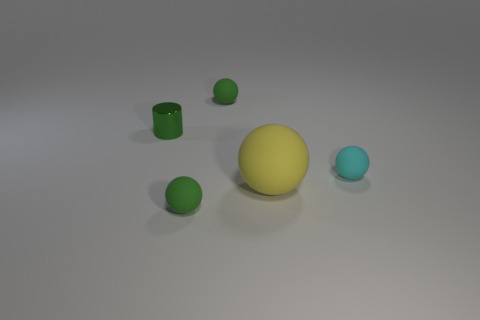Add 2 small green shiny cylinders. How many objects exist? 7 Subtract all balls. How many objects are left? 1 Add 4 green matte balls. How many green matte balls exist? 6 Subtract 0 blue spheres. How many objects are left? 5 Subtract all small cyan balls. Subtract all tiny yellow metal things. How many objects are left? 4 Add 4 tiny matte objects. How many tiny matte objects are left? 7 